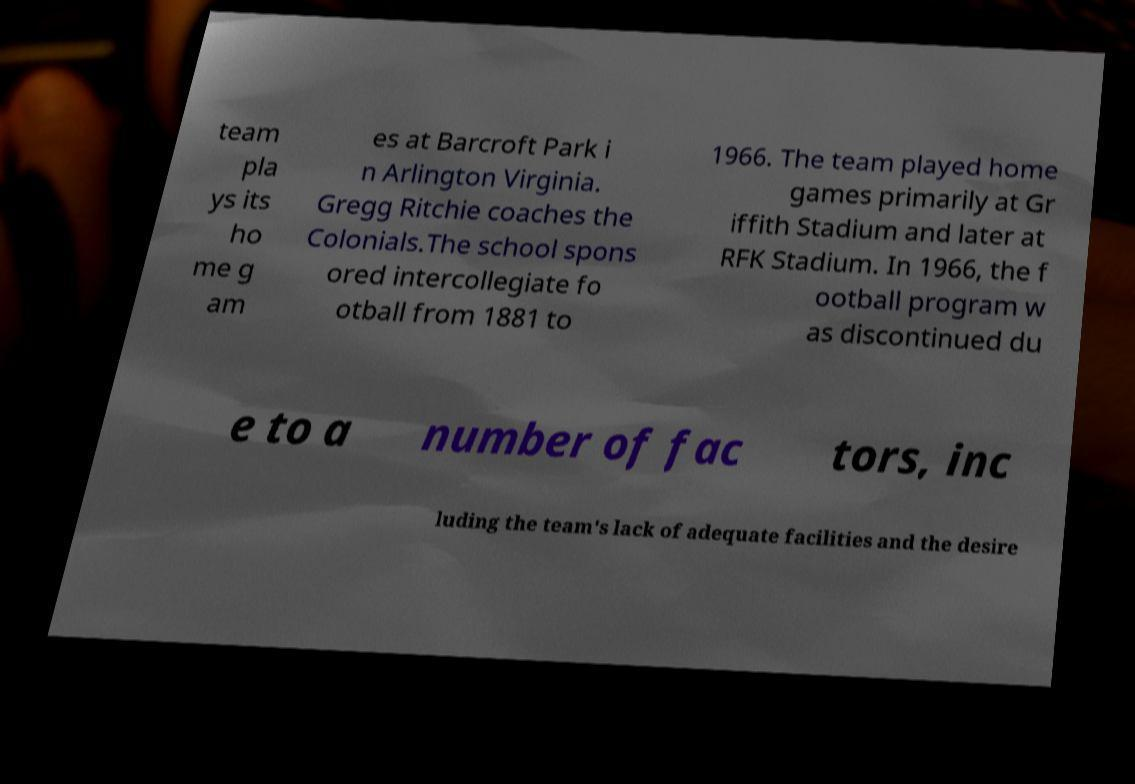Can you read and provide the text displayed in the image?This photo seems to have some interesting text. Can you extract and type it out for me? team pla ys its ho me g am es at Barcroft Park i n Arlington Virginia. Gregg Ritchie coaches the Colonials.The school spons ored intercollegiate fo otball from 1881 to 1966. The team played home games primarily at Gr iffith Stadium and later at RFK Stadium. In 1966, the f ootball program w as discontinued du e to a number of fac tors, inc luding the team's lack of adequate facilities and the desire 